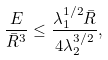<formula> <loc_0><loc_0><loc_500><loc_500>\frac { E } { \bar { R } ^ { 3 } } \leq \frac { \lambda _ { 1 } ^ { 1 / 2 } \bar { R } } { 4 \lambda _ { 2 } ^ { 3 / 2 } } ,</formula> 